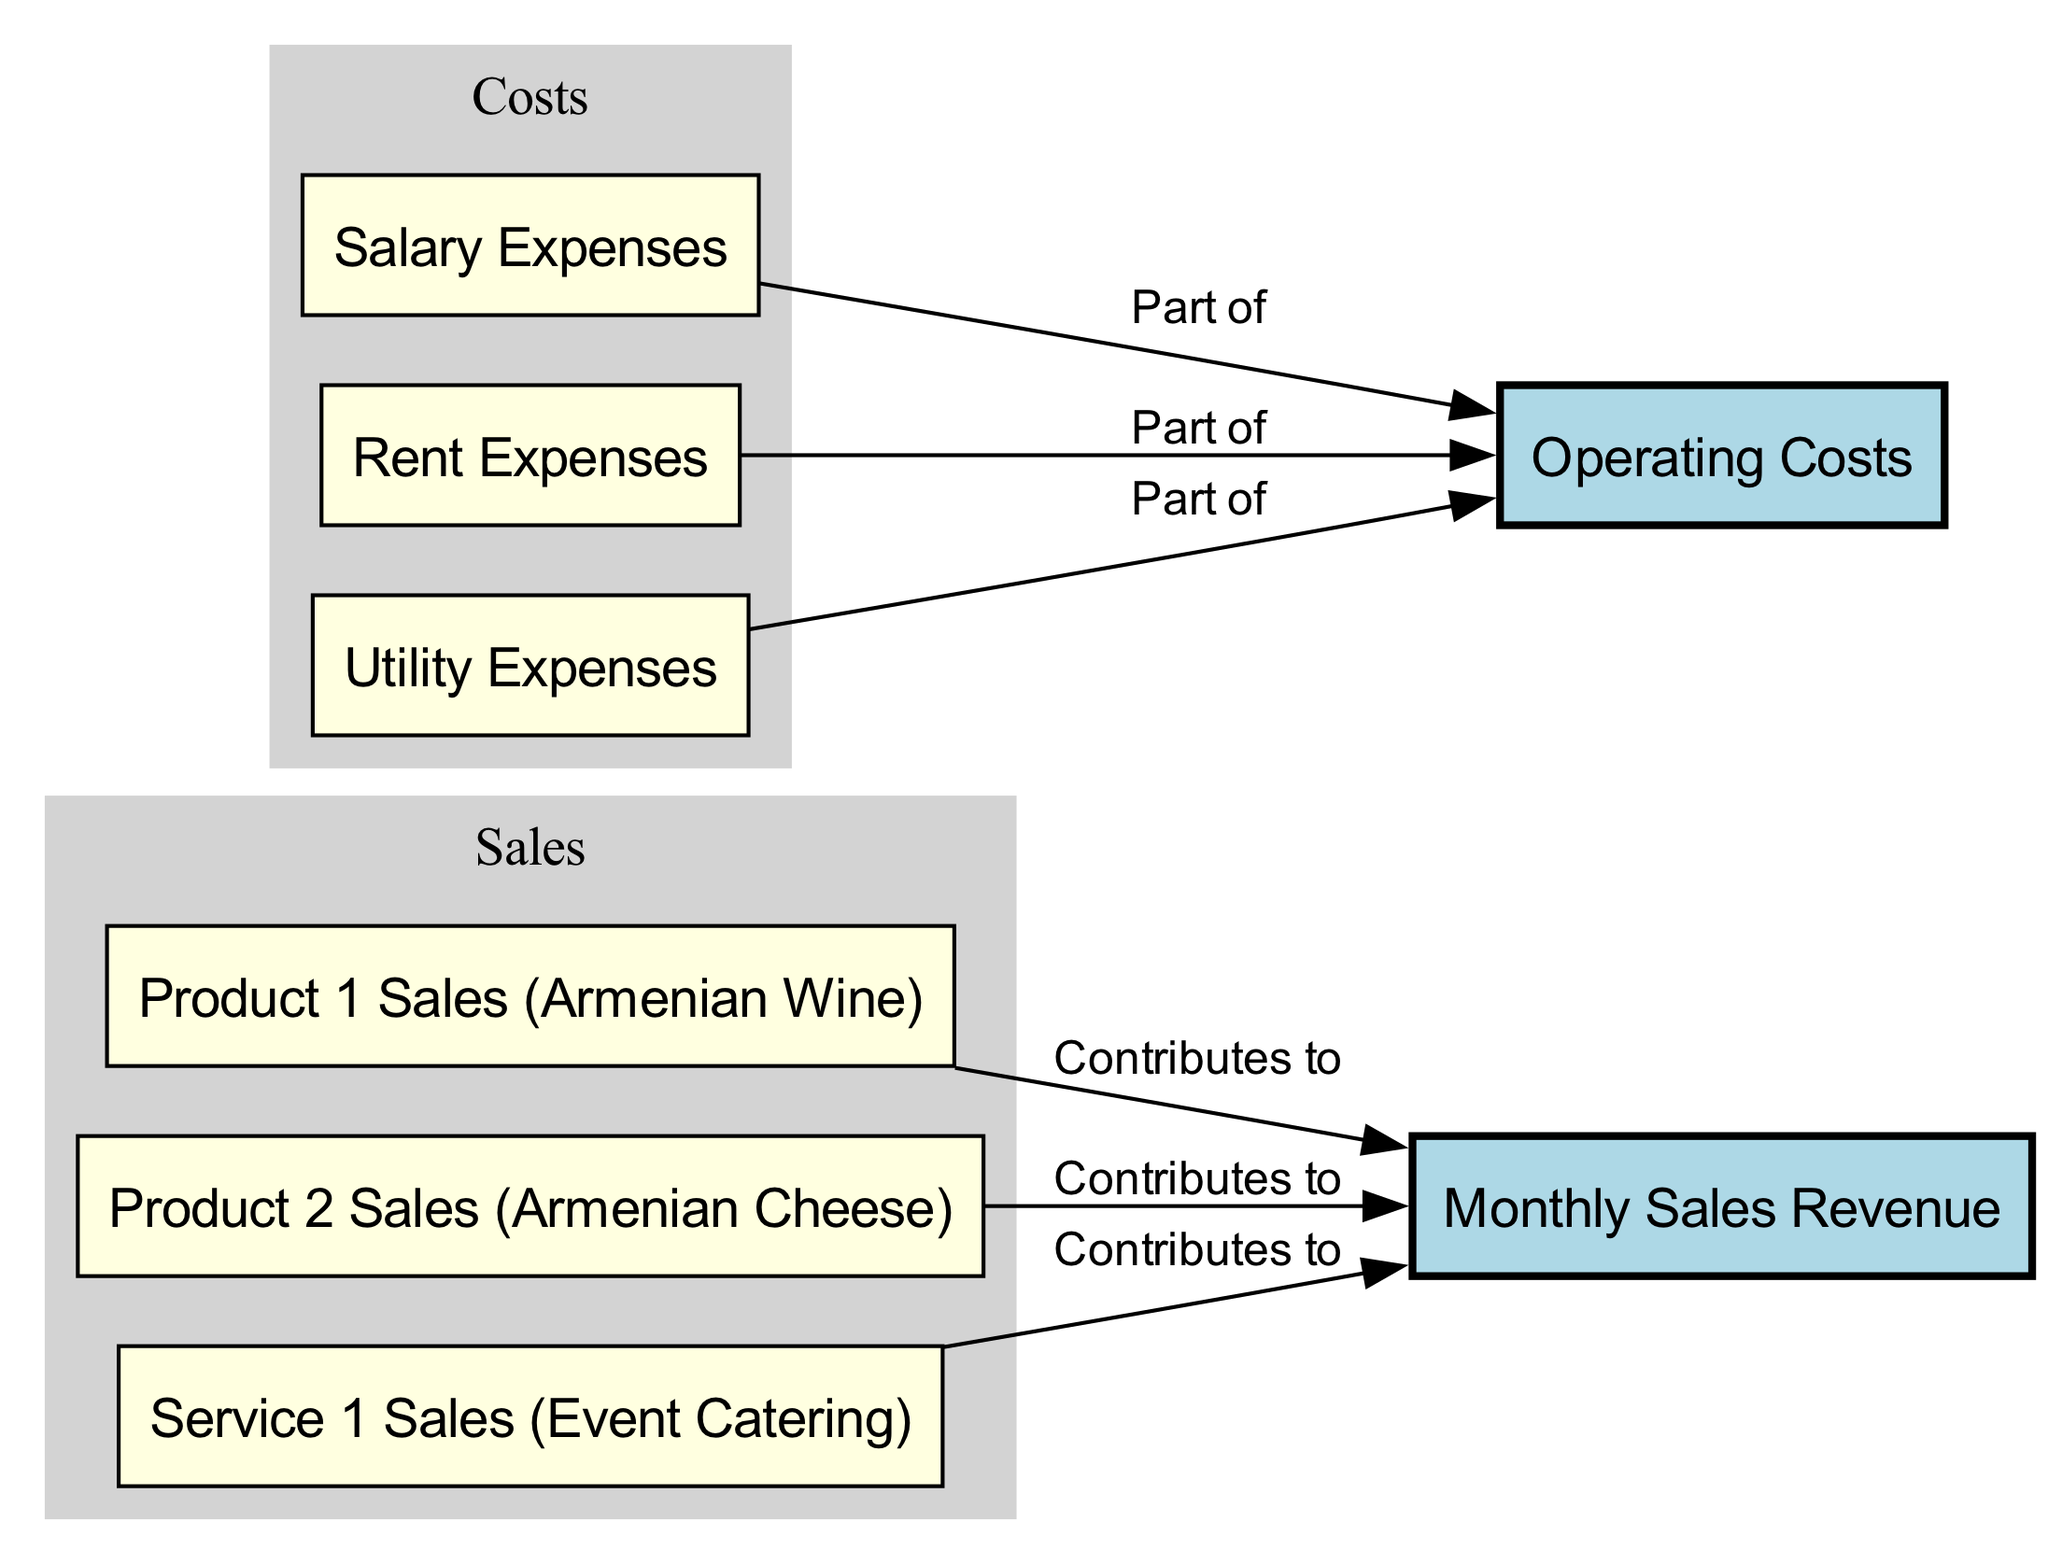What are the three main products/services contributing to monthly sales revenue? The diagram shows three sub-nodes connected to the "Monthly Sales Revenue" node: "Product 1 Sales (Armenian Wine)," "Product 2 Sales (Armenian Cheese)," and "Service 1 Sales (Event Catering)." These three are the main contributors listed.
Answer: Armenian Wine, Armenian Cheese, Event Catering How many sub-nodes are related to operating costs? The diagram has three sub-nodes contributing to "Operating Costs": "Salary Expenses," "Rent Expenses," and "Utility Expenses." The count of these sub-nodes gives the answer.
Answer: 3 Which expense type contributes to operating costs related to space usage? Looking at the diagram, "Rent Expenses" directly relates to "Operating Costs" and represents the cost associated with space usage.
Answer: Rent Expenses What is the relationship between Product 2 Sales and Monthly Sales Revenue? The diagram indicates that "Product 2 Sales (Armenian Cheese)" has a directed edge pointing to "Monthly Sales Revenue," labeled as "Contributes to." This shows that Product 2 contributes directly to overall sales revenue.
Answer: Contributes to What costs are classified as expenses besides salaries in the operating costs? Upon examining the operating costs section, aside from "Salary Expenses," there are "Rent Expenses" and "Utility Expenses." These two are also classified as operating costs.
Answer: Rent Expenses, Utility Expenses If the total monthly sales revenue was 1,000,000 AMD, what can be inferred about individual contributions? Though the diagram does not provide specific figures, one can infer that each product/service contributes some portion of the 1,000,000 AMD total monthly sales revenue, indicating their shared responsibility for the overall amount.
Answer: Shared responsibility Which element of the diagram represents the combined costs of running the business? The "Operating Costs" node compiles all costs associated with running the business, including salaries, rent, and utilities.
Answer: Operating Costs How does the diagram categorize financial flows? The diagram differentiates the financial flows into two main categories: "Monthly Sales Revenue," which represents income, and "Operating Costs," which encompasses various expenses. This division highlights income versus outgoing costs within the business model.
Answer: Two main categories 